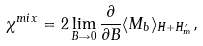Convert formula to latex. <formula><loc_0><loc_0><loc_500><loc_500>\chi ^ { m i x } = 2 \lim _ { B \rightarrow 0 } \frac { \partial } { \partial B } \langle M _ { b } \rangle _ { H + H ^ { \prime } _ { m } } ,</formula> 